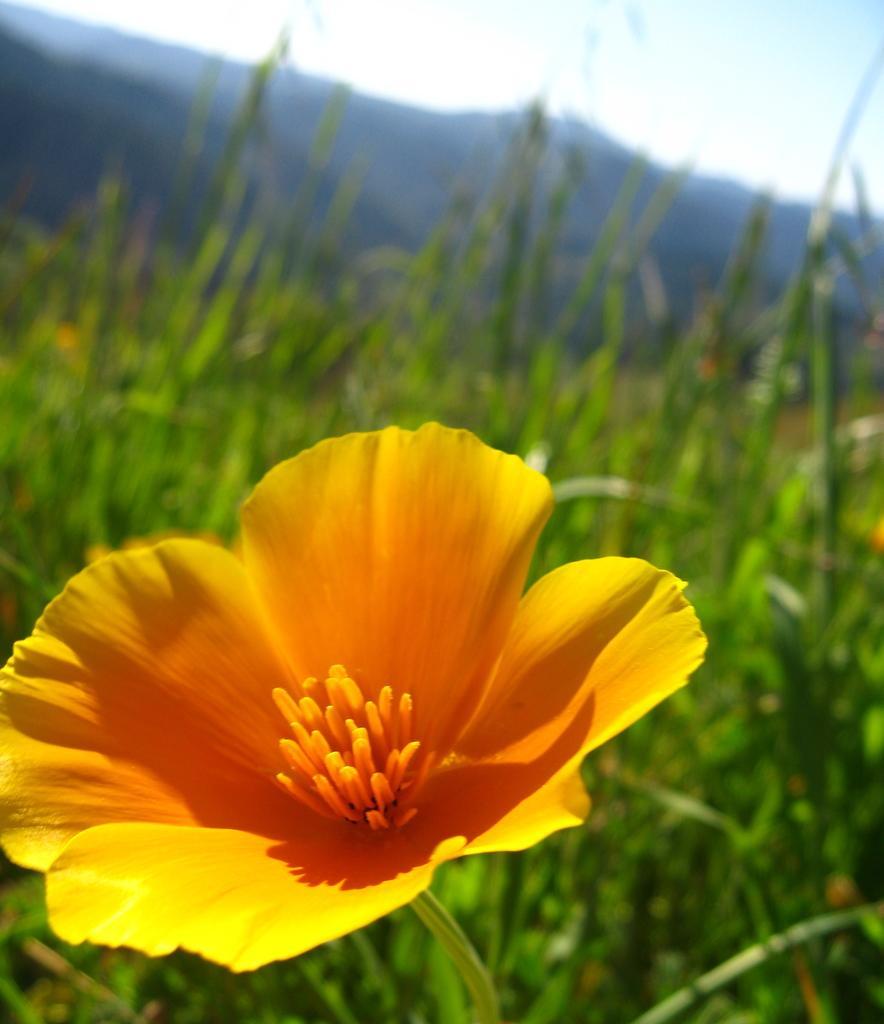Please provide a concise description of this image. In this image there is a flower which is in yellow color. Background there are few plants. Behind there is a hill. Top of the image there is sky. 